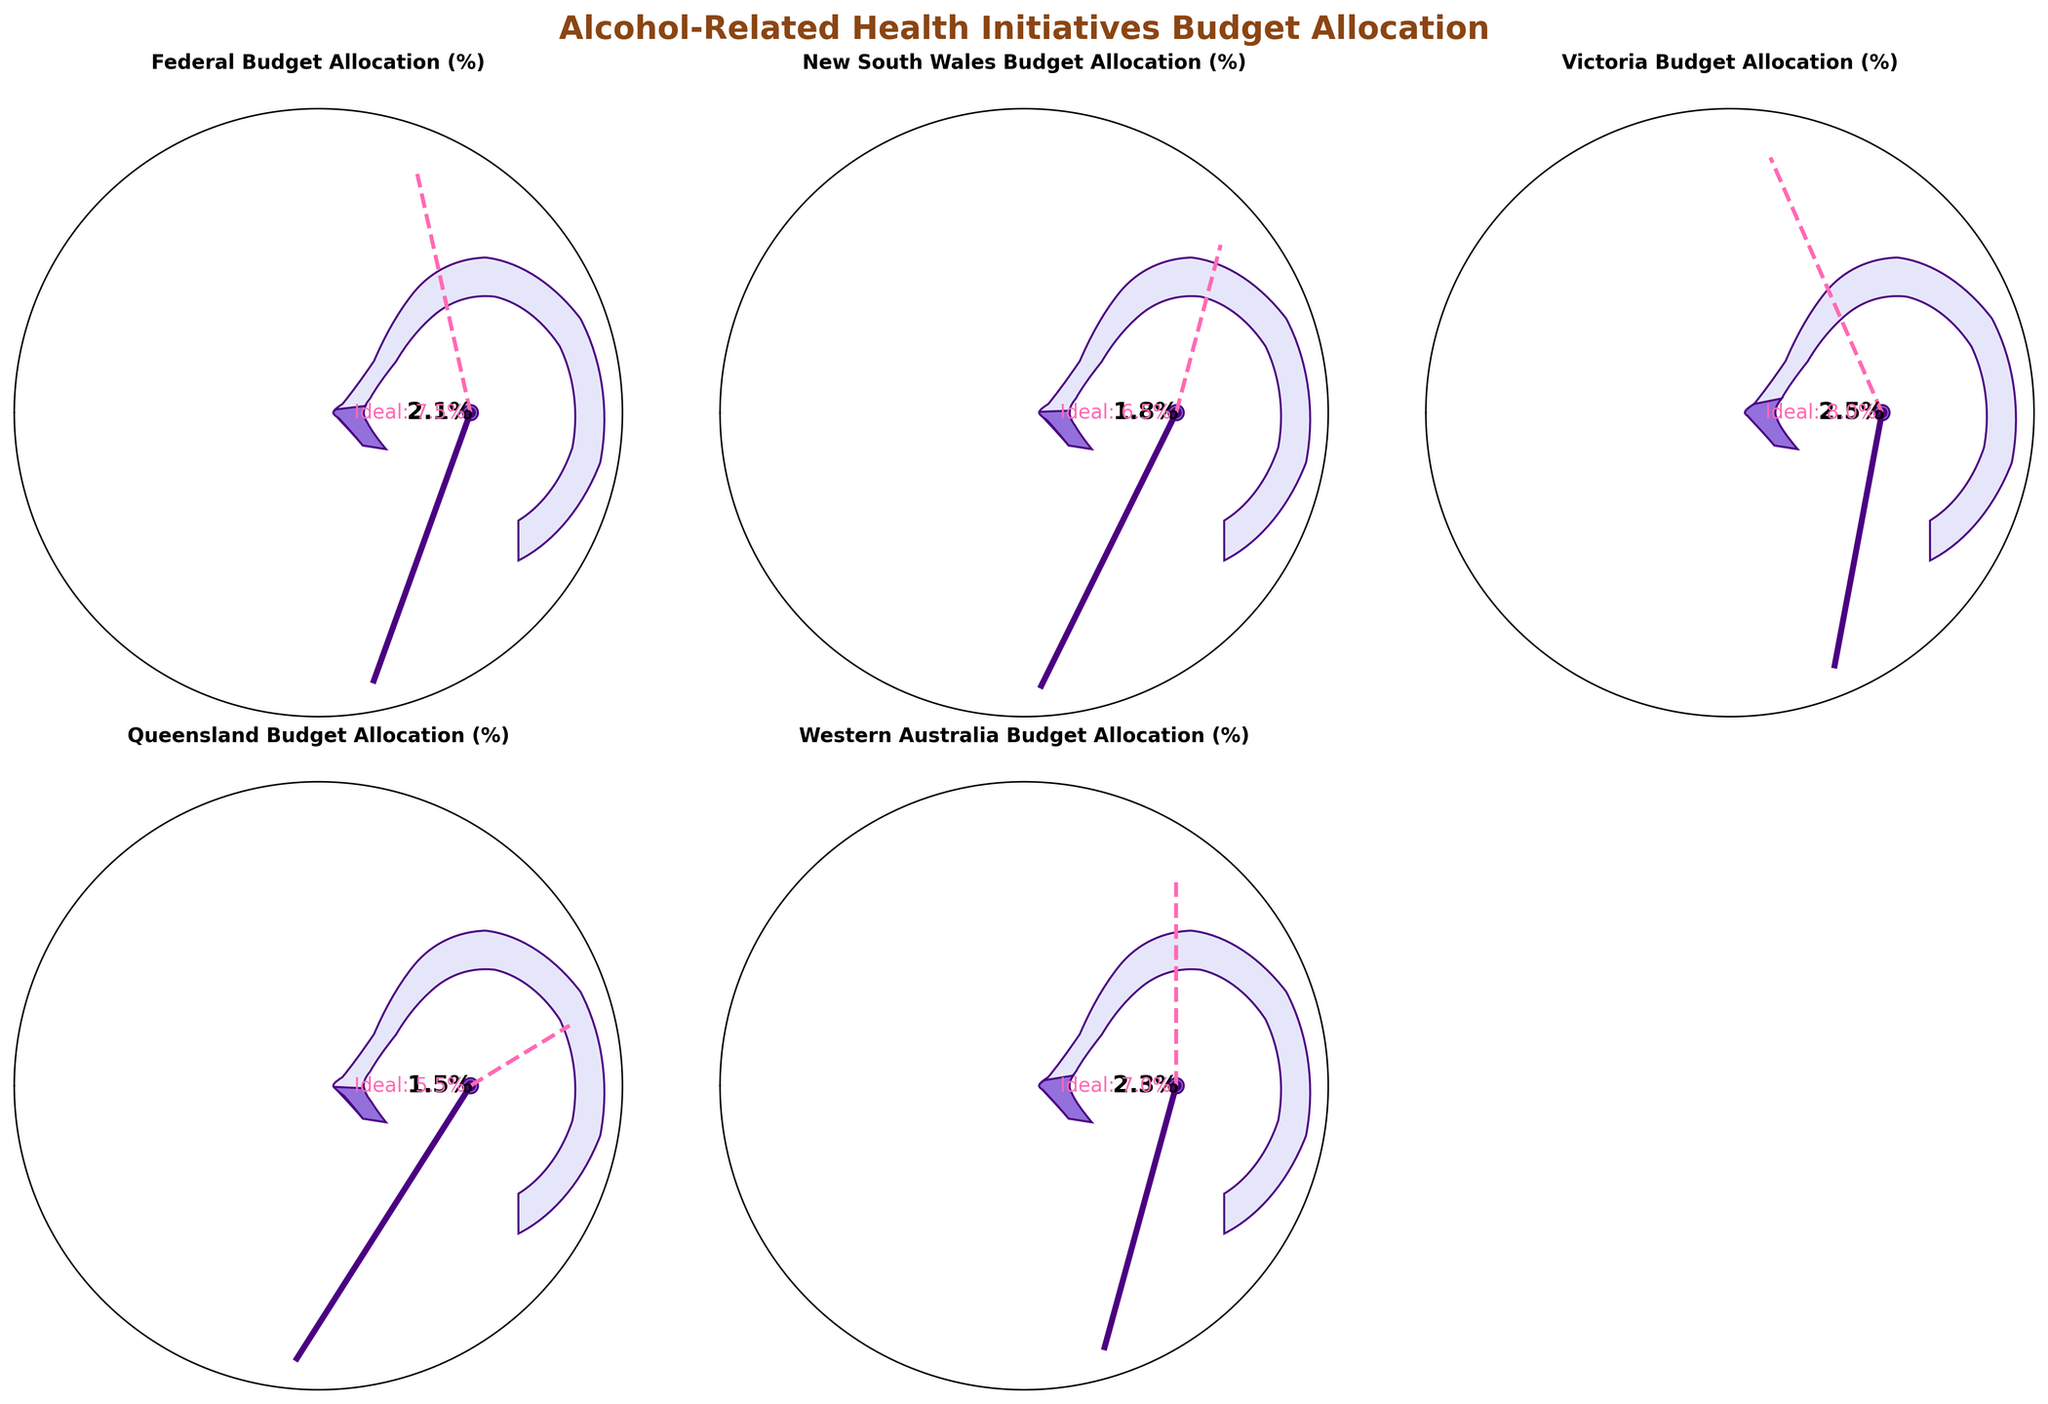What's the title of the figure? The title is displayed at the top of the figure in bold, specifying the subject of the visualized data.
Answer: Alcohol-Related Health Initiatives Budget Allocation Which budget allocation category is represented in the top left gauge? By looking at the category label at the top of each gauge, we can identify the specific budget allocation represented. The top left gauge is labeled 'Federal Budget Allocation (%)'.
Answer: Federal Budget Allocation (%) What is the actual percentage allocated by Queensland? In the gauge for Queensland, the value in percentage is shown at the bottom of the gauge inside the circle.
Answer: 1.5% Which state has the highest target allocation percentage? By comparing all the 'Ideal' values specified around each gauge, we can identify the state with the highest target allocation. Victoria has the highest, with an ideal of 8.0%.
Answer: Victoria Compare the actual and ideal allocations for New South Wales. How different are they? For New South Wales, the actual allocation is 1.8%, and the ideal is 6.5%. The difference is calculated by subtracting the actual from the ideal: \( 6.5 - 1.8 = 4.7 \).
Answer: 4.7% In which state is the actual percentage closest to the ideal target? By comparing the actual allocation to the ideal value in each gauge chart, Western Australia has an actual value of 2.3% and an ideal of 7.0%, showing one of the smallest differences.
Answer: Western Australia Which state shows the lowest actual allocation percentage for alcohol-related health initiatives? By checking each gauge for the actual percentage values, we see that Queensland has the lowest at 1.5%.
Answer: Queensland How many states have actual allocations above 2.0%? By examining each gauge for the actual allocation percentages, we identify that only Victoria (2.5%) and Western Australia (2.3%) have allocations above 2.0%.
Answer: 2 Is the actual allocation for New South Wales less than that of Victoria? By comparing the actual allocation values, New South Wales (1.8%) has a lower value than Victoria (2.5%).
Answer: Yes What is the average ideal allocation percentage across all the categories? Adding the ideal values for all categories: \( 7.5 + 6.5 + 8.0 + 5.5 + 7.0 \) and then dividing by 5: \( (7.5 + 6.5 + 8.0 + 5.5 + 7.0) / 5 = 6.9 \).
Answer: 6.9% 